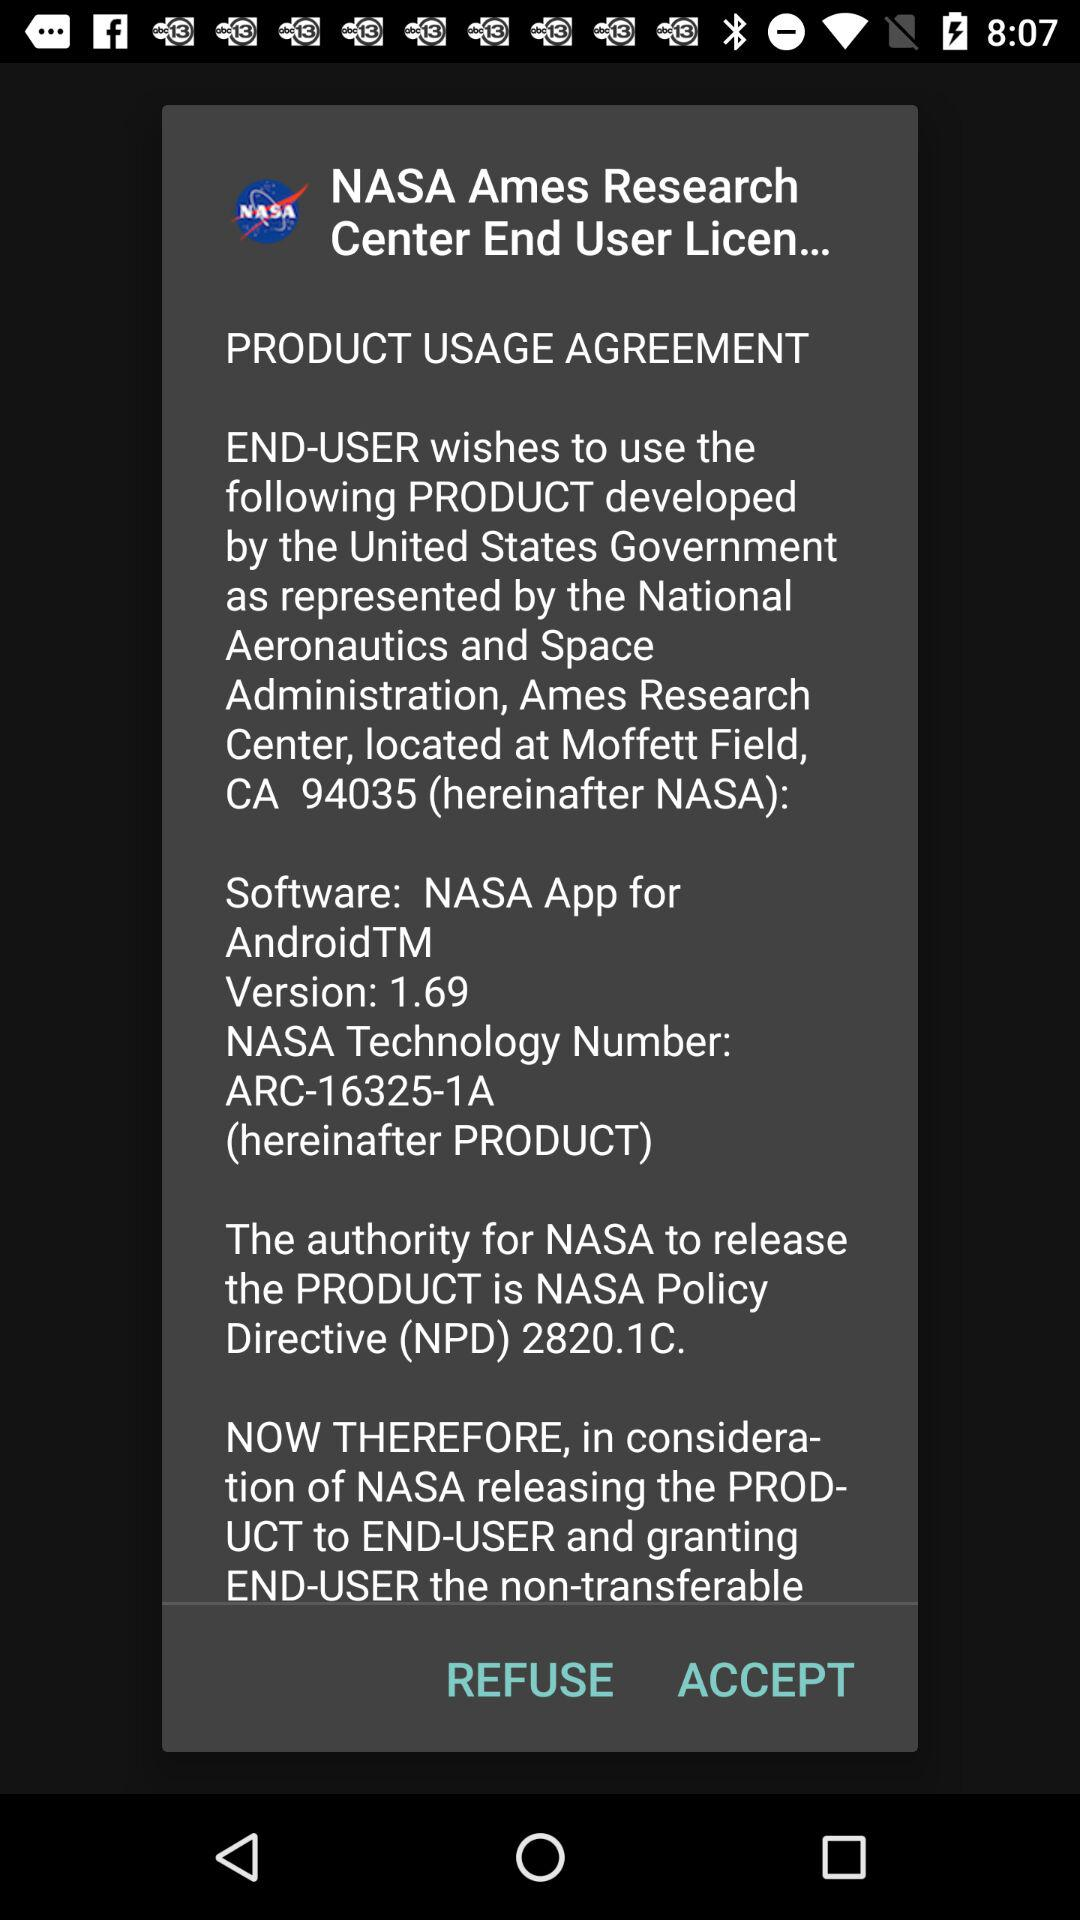What is the application version? The application version is 1.69. 